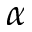<formula> <loc_0><loc_0><loc_500><loc_500>\alpha</formula> 